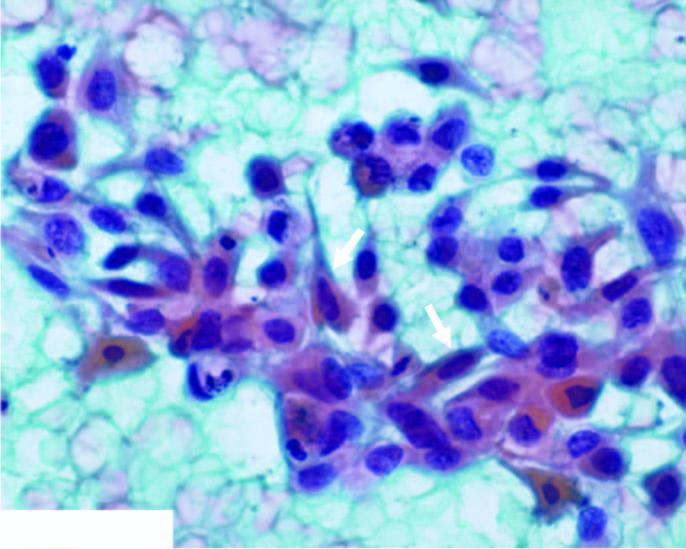does the background show abundant haemorrhage and some necrotic debris?
Answer the question using a single word or phrase. Yes 